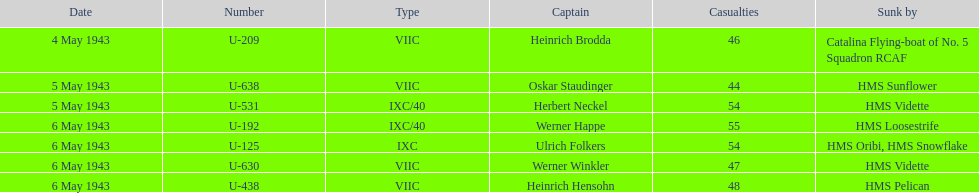What is the unique vessel to sink various u-boats? HMS Vidette. 